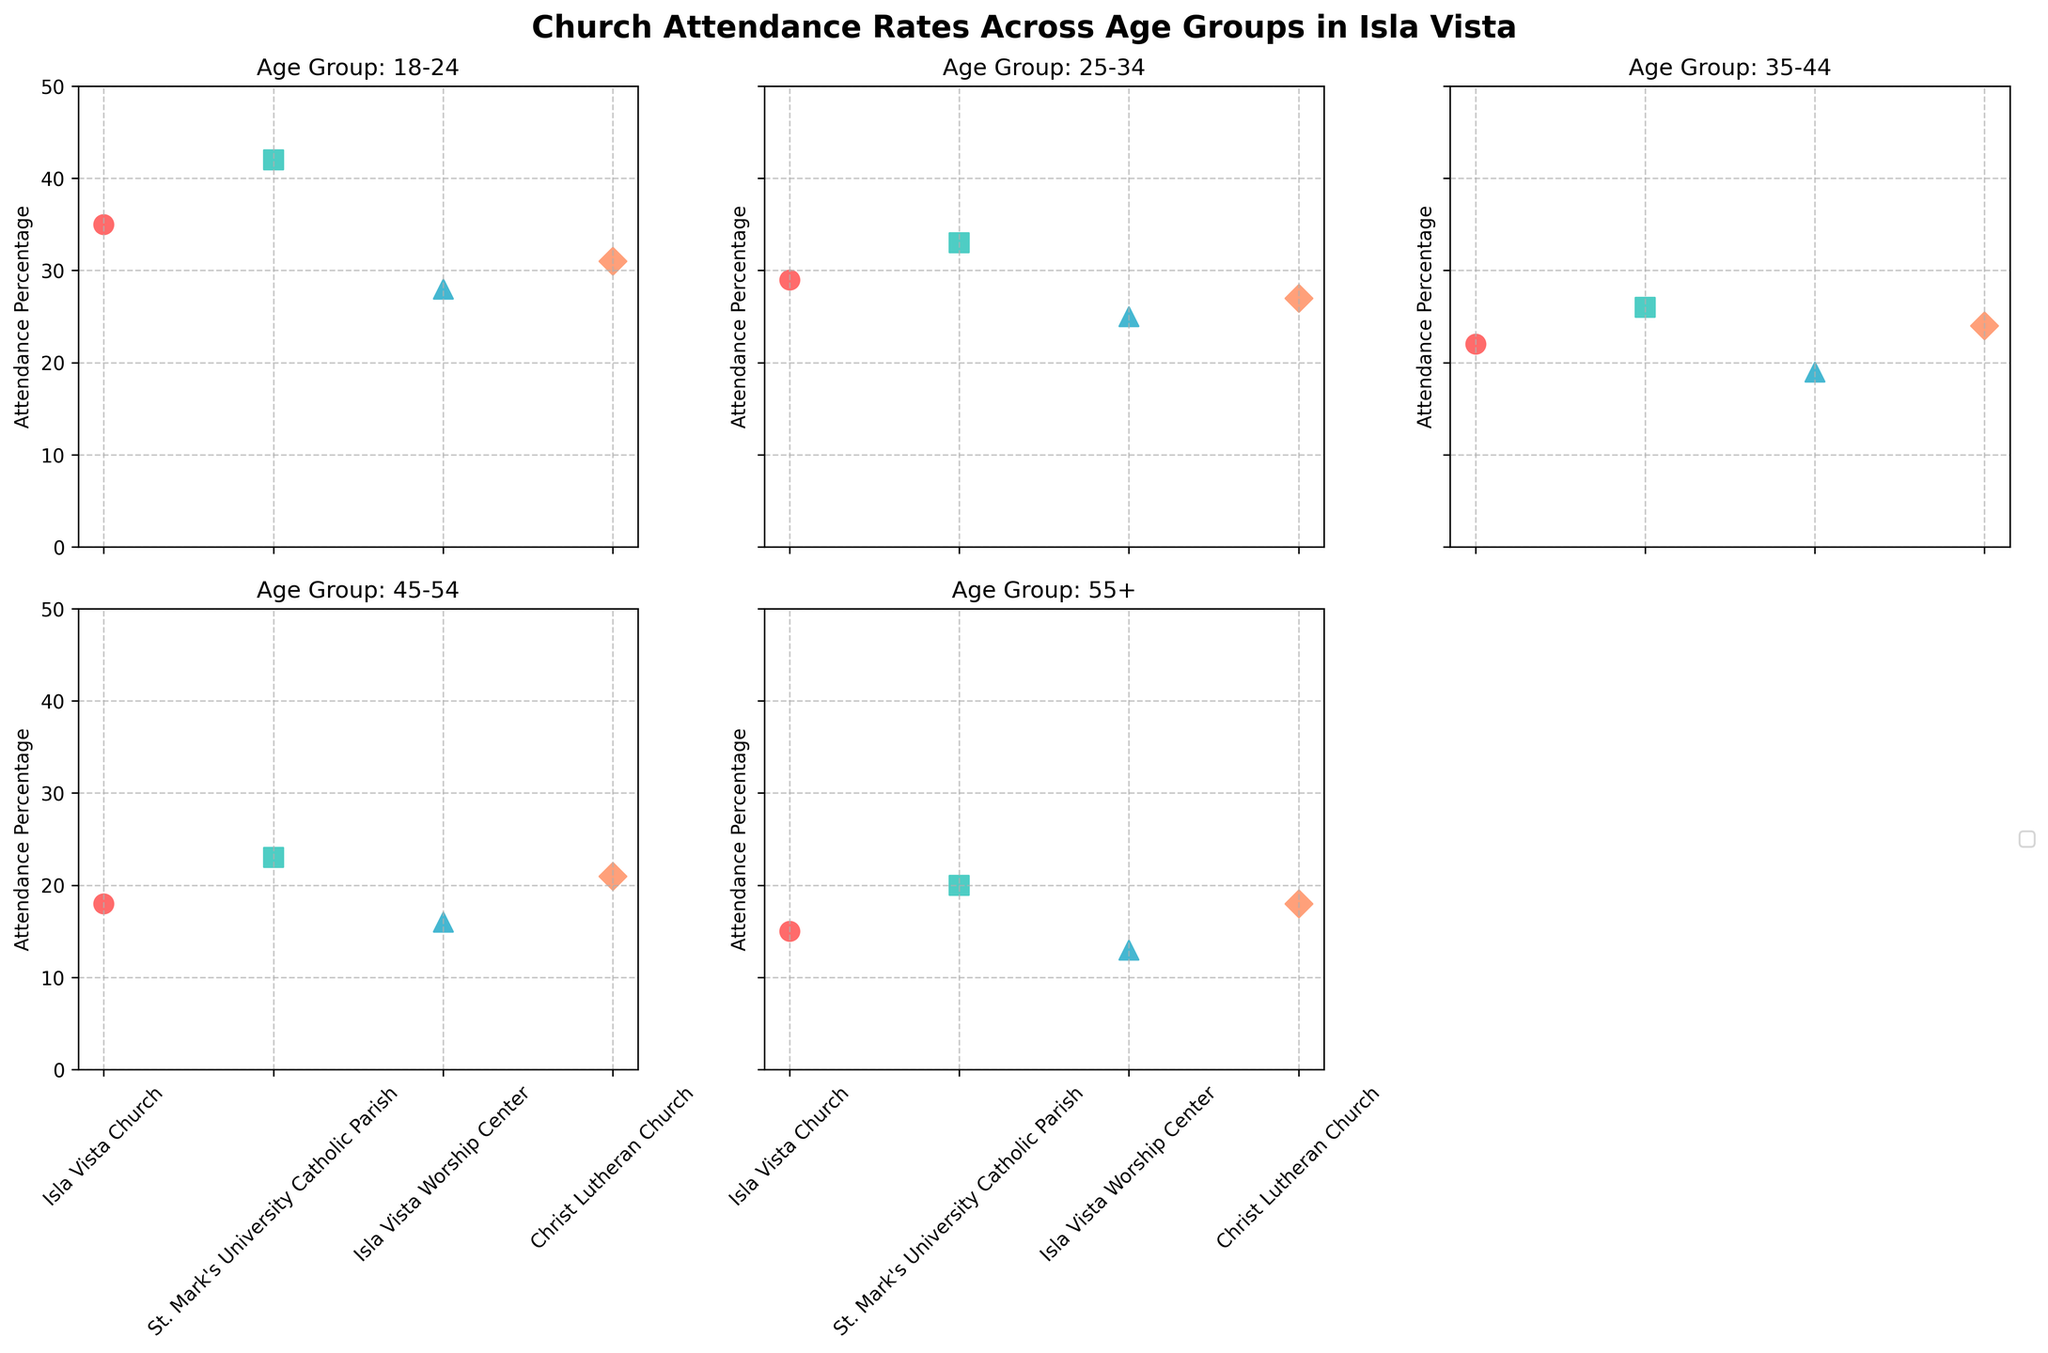What is the title of the figure? The title is located at the top and is clearly visible as the main descriptor of the entire plot.
Answer: Church Attendance Rates Across Age Groups in Isla Vista Which church has the highest attendance percentage for the 18-24 age group? In the subplot for the 18-24 age group, the scatter point for St. Mark's University Catholic Parish is at the highest position.
Answer: St. Mark's University Catholic Parish What is the average attendance percentage for the 25-34 age group across all churches? The attendance percentages for the 25-34 age group are 29, 33, 25, and 27. Summing these gives 114, and dividing by the number of churches (4) provides the average: 114 / 4 = 28.5.
Answer: 28.5 How does the attendance percentage for Isla Vista Church compare between the 18-24 and 55+ age groups? For Isla Vista Church, the attendance percentage is 35 for 18-24 and 15 for 55+. 35 is greater than 15.
Answer: 18-24 is higher What is the trend in attendance percentage for Christ Lutheran Church as age increases? Observing the scatter points for Christ Lutheran Church across age groups (31, 27, 24, 21, 18), the attendance percentage decreases as the age group increases.
Answer: Decreasing Which age group has the lowest attendance percentage for Isla Vista Worship Center? The scatter point for the 55+ age group is the lowest in the Isla Vista Worship Center subplot (13%).
Answer: 55+ Is there a church that consistently has the highest attendance across all age groups? No single church consistently holds the highest attendance percentage across all age groups when examining the subplots for each age group.
Answer: No What is the range of attendance percentages for the 45-54 age group? For the 45-54 age group, the attendance percentages are 18, 23, 16, and 21. The range is calculated by subtracting the smallest value (16) from the largest value (23): 23 - 16 = 7.
Answer: 7 Which church shows the greatest decrease in attendance percentage from 18-24 to 55+ age groups? Calculating the differences for each church: Isla Vista Church (35 - 15 = 20), St. Mark's University Catholic Parish (42 - 20 = 22), Isla Vista Worship Center (28 - 13 = 15), Christ Lutheran Church (31 - 18 = 13), the greatest decrease is for St. Mark's University Catholic Parish.
Answer: St. Mark's University Catholic Parish 